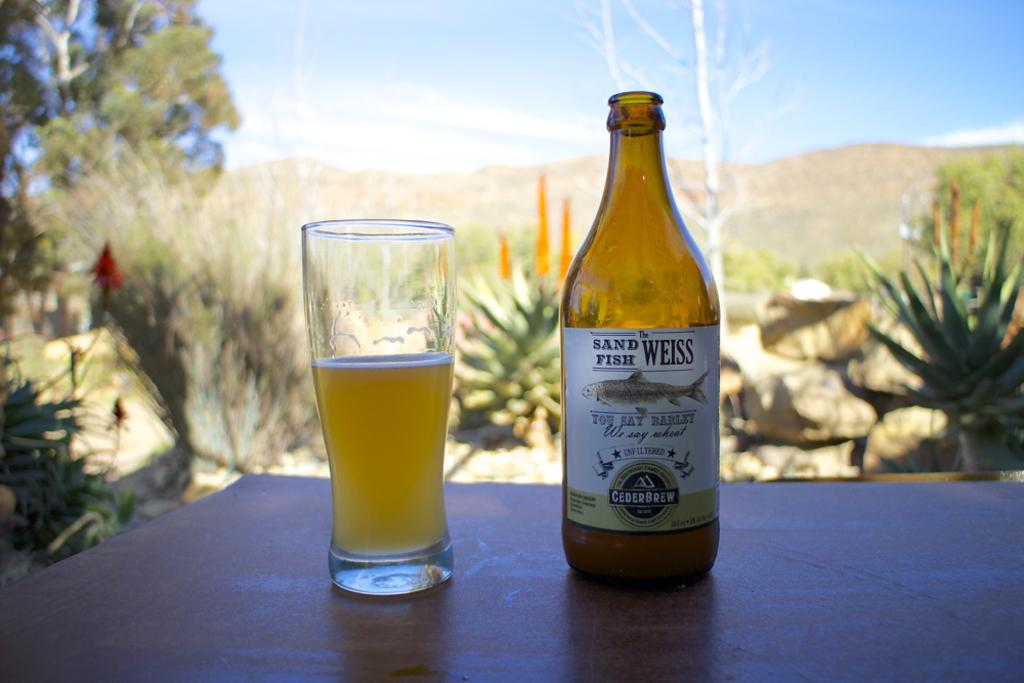Provide a one-sentence caption for the provided image. Full glass and bottle of Sand Fish Weiss you say barley we say wheat brand of beer on a table. 